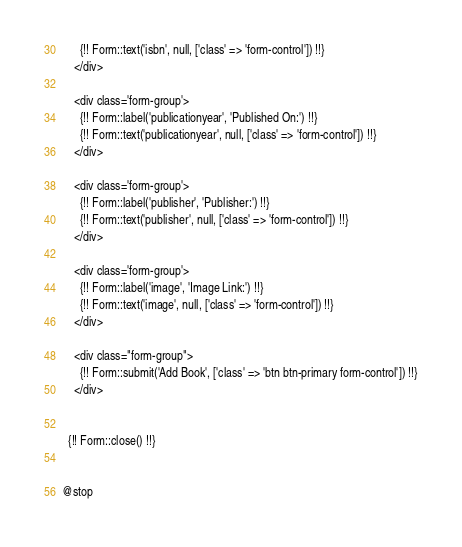<code> <loc_0><loc_0><loc_500><loc_500><_PHP_>      {!! Form::text('isbn', null, ['class' => 'form-control']) !!}
    </div>

    <div class='form-group'>
      {!! Form::label('publicationyear', 'Published On:') !!}
      {!! Form::text('publicationyear', null, ['class' => 'form-control']) !!}
    </div>

    <div class='form-group'>
      {!! Form::label('publisher', 'Publisher:') !!}
      {!! Form::text('publisher', null, ['class' => 'form-control']) !!}
    </div>

    <div class='form-group'>
      {!! Form::label('image', 'Image Link:') !!}
      {!! Form::text('image', null, ['class' => 'form-control']) !!}
    </div>

    <div class="form-group">
      {!! Form::submit('Add Book', ['class' => 'btn btn-primary form-control']) !!}
    </div>


  {!! Form::close() !!}


@stop
</code> 